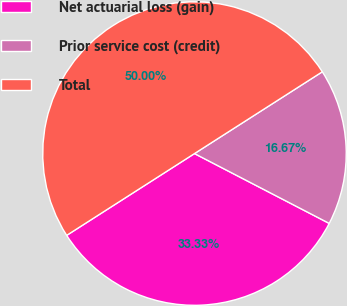Convert chart to OTSL. <chart><loc_0><loc_0><loc_500><loc_500><pie_chart><fcel>Net actuarial loss (gain)<fcel>Prior service cost (credit)<fcel>Total<nl><fcel>33.33%<fcel>16.67%<fcel>50.0%<nl></chart> 